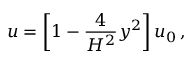Convert formula to latex. <formula><loc_0><loc_0><loc_500><loc_500>u = \left [ 1 - { \frac { 4 } { H ^ { 2 } } } y ^ { 2 } \right ] u _ { 0 } \, ,</formula> 